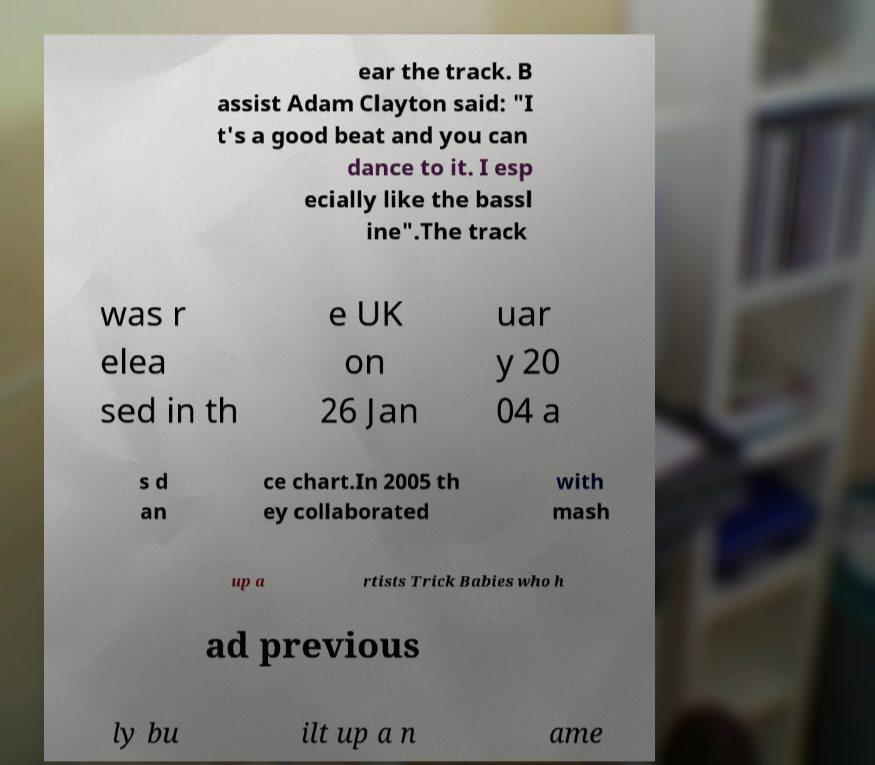Could you assist in decoding the text presented in this image and type it out clearly? ear the track. B assist Adam Clayton said: "I t's a good beat and you can dance to it. I esp ecially like the bassl ine".The track was r elea sed in th e UK on 26 Jan uar y 20 04 a s d an ce chart.In 2005 th ey collaborated with mash up a rtists Trick Babies who h ad previous ly bu ilt up a n ame 